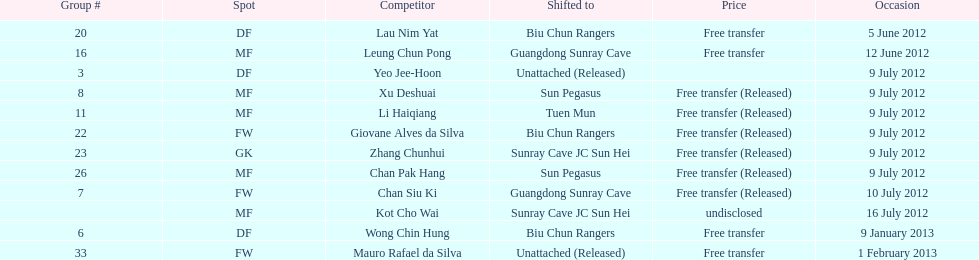Lau nim yat and giovane alves de silva where both transferred to which team? Biu Chun Rangers. 